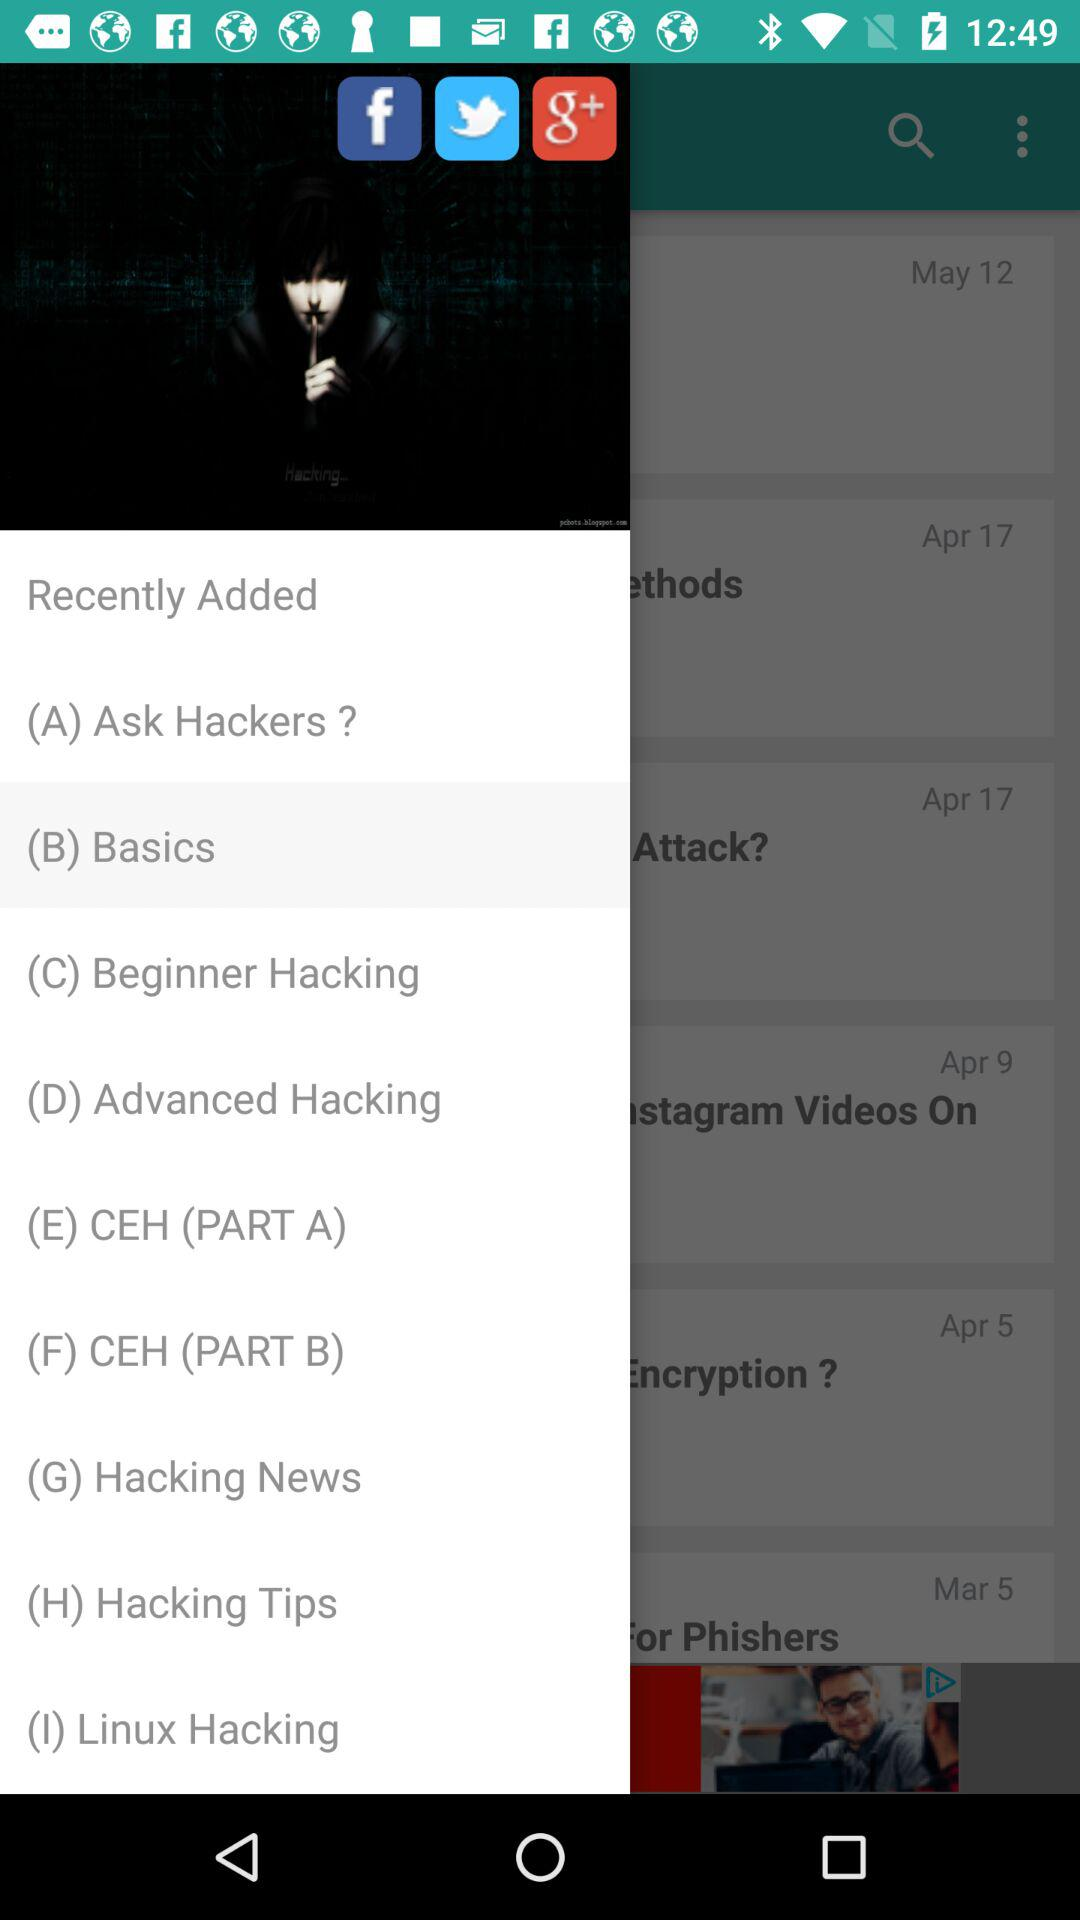What are the recently added items? The recently added items are "Ask Hackers?", "Basics", "Beginner Hacking", "Advanced Hacking", "CEH (PART A)", "CEH (PART B)", "Hacking News", "Hacking Tips" and "Linux Hacking". 